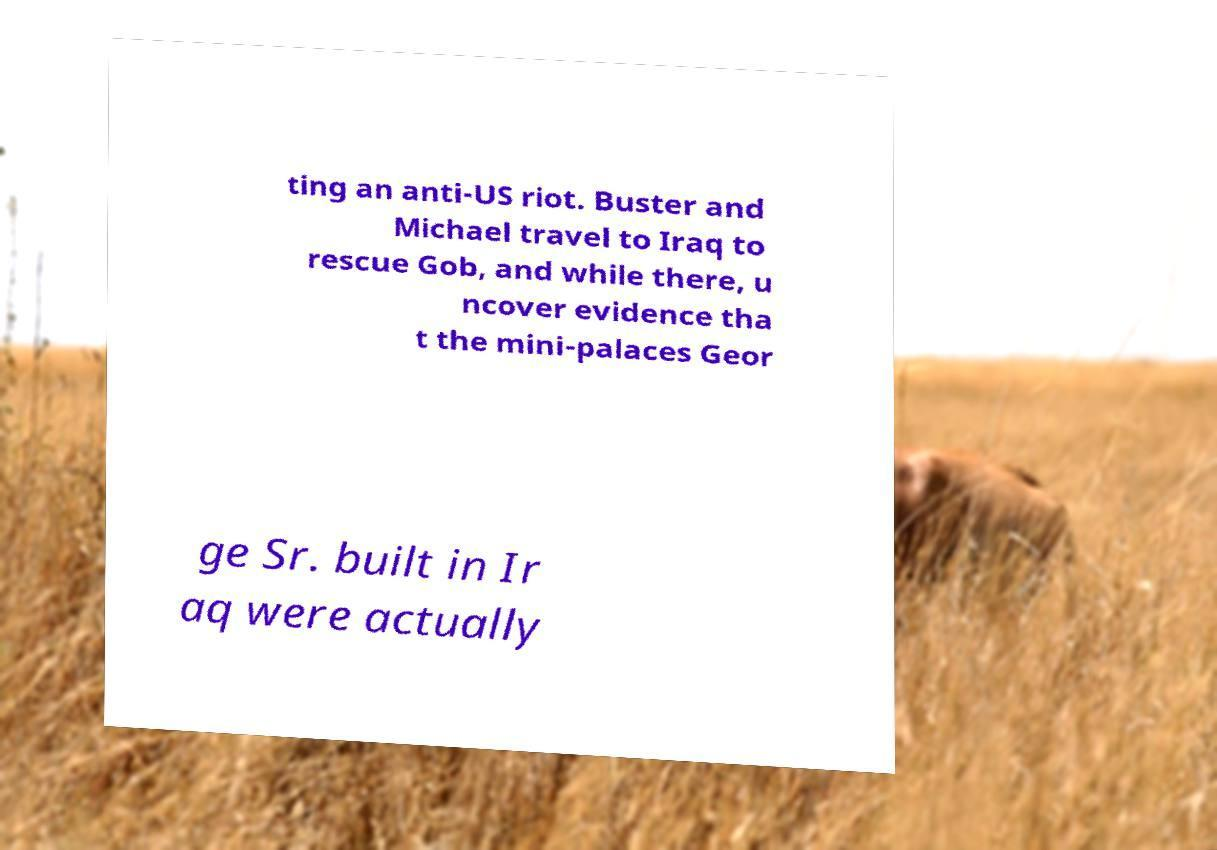What messages or text are displayed in this image? I need them in a readable, typed format. ting an anti-US riot. Buster and Michael travel to Iraq to rescue Gob, and while there, u ncover evidence tha t the mini-palaces Geor ge Sr. built in Ir aq were actually 